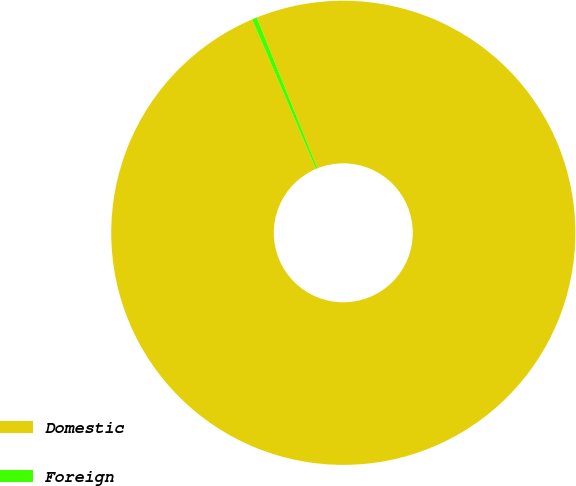<chart> <loc_0><loc_0><loc_500><loc_500><pie_chart><fcel>Domestic<fcel>Foreign<nl><fcel>99.66%<fcel>0.34%<nl></chart> 